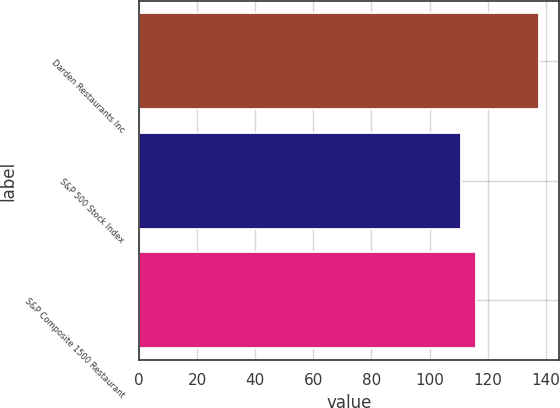<chart> <loc_0><loc_0><loc_500><loc_500><bar_chart><fcel>Darden Restaurants Inc<fcel>S&P 500 Stock Index<fcel>S&P Composite 1500 Restaurant<nl><fcel>137.7<fcel>110.88<fcel>115.96<nl></chart> 